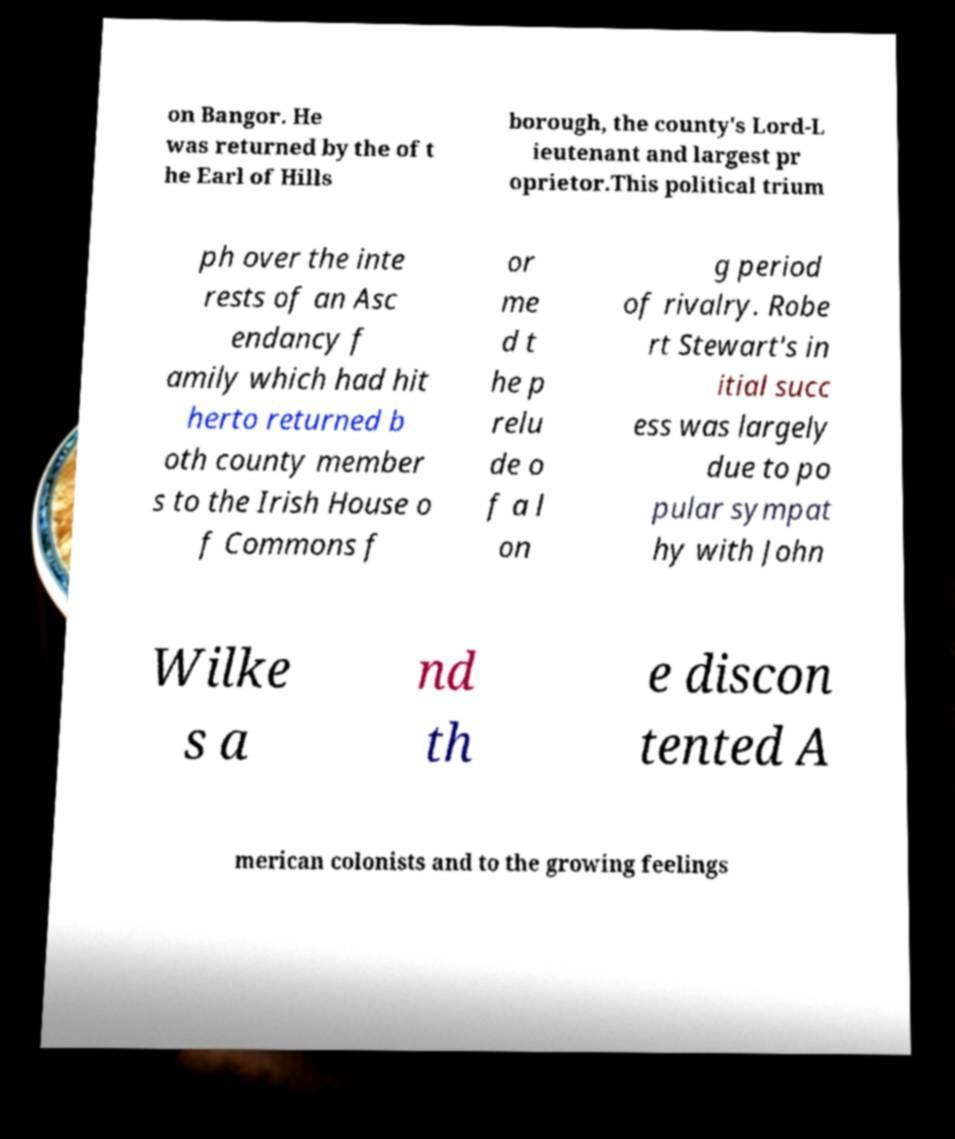Can you read and provide the text displayed in the image?This photo seems to have some interesting text. Can you extract and type it out for me? on Bangor. He was returned by the of t he Earl of Hills borough, the county's Lord-L ieutenant and largest pr oprietor.This political trium ph over the inte rests of an Asc endancy f amily which had hit herto returned b oth county member s to the Irish House o f Commons f or me d t he p relu de o f a l on g period of rivalry. Robe rt Stewart's in itial succ ess was largely due to po pular sympat hy with John Wilke s a nd th e discon tented A merican colonists and to the growing feelings 